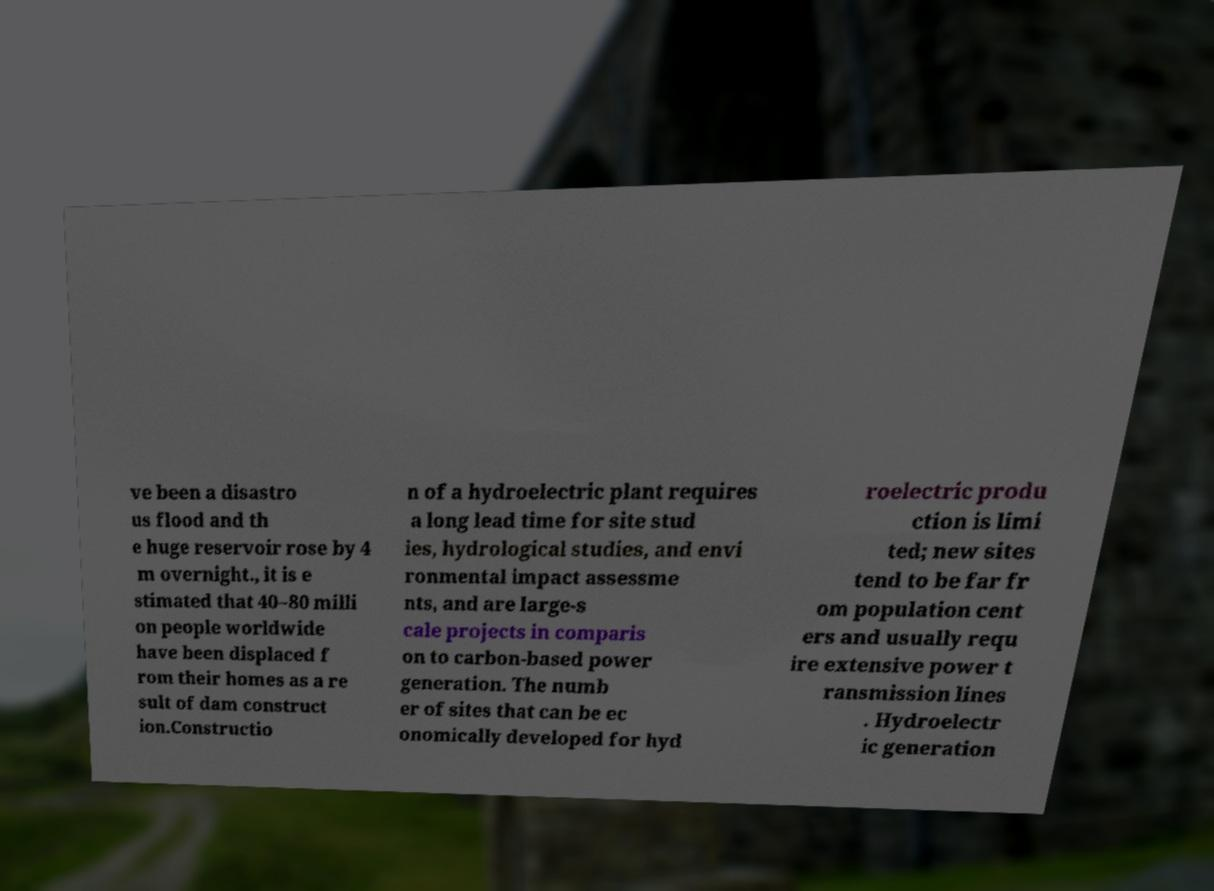What messages or text are displayed in this image? I need them in a readable, typed format. ve been a disastro us flood and th e huge reservoir rose by 4 m overnight., it is e stimated that 40–80 milli on people worldwide have been displaced f rom their homes as a re sult of dam construct ion.Constructio n of a hydroelectric plant requires a long lead time for site stud ies, hydrological studies, and envi ronmental impact assessme nts, and are large-s cale projects in comparis on to carbon-based power generation. The numb er of sites that can be ec onomically developed for hyd roelectric produ ction is limi ted; new sites tend to be far fr om population cent ers and usually requ ire extensive power t ransmission lines . Hydroelectr ic generation 